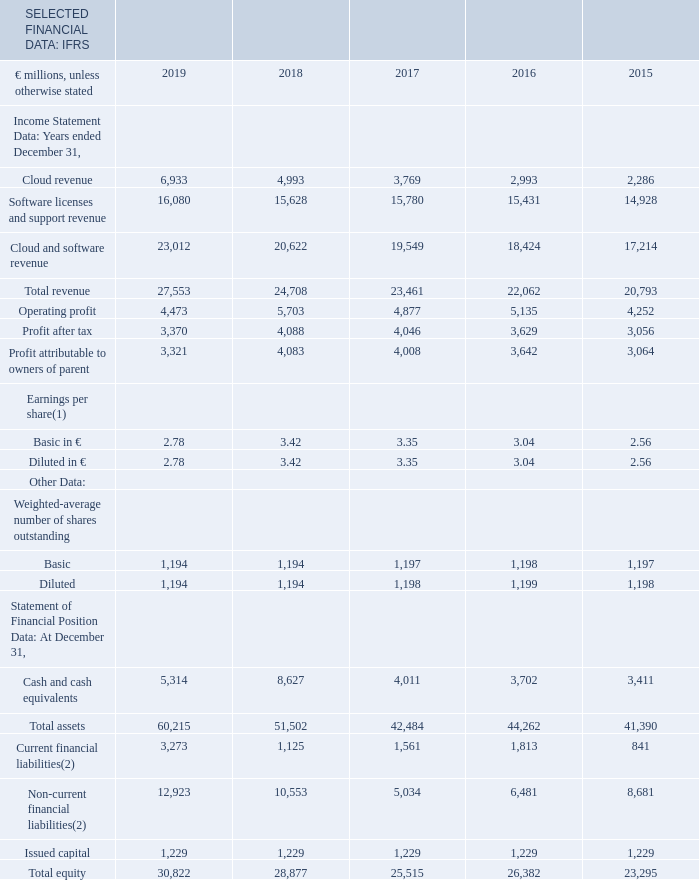ITEM 3. KEY INFORMATION
Selected Financial Data
The following table sets forth our selected consolidated financial data as of and for each of the years in the five-year period ended December 31, 2019. The consolidated financial data has been derived from, and should be read in conjunction with, our Consolidated Financial Statements prepared in accordance with International Financial Reporting Standards as issued by the International Accounting Standards Board (IFRS), presented in “Item 18. Financial Statements” of this report.
Our selected financial data and our Consolidated Financial Statements are presented in euros, unless otherwise stated.
(1) See Note (C.6) to our Consolidated Financial Statements for more information on earnings per share.
(2) The balances include primarily bonds, private placements and bank loans. See Note (E.3) to our Consolidated Financial Statements for more information on our financial liabilities.
Where is more information on earnings per share provided? Note (c.6) to our consolidated financial statements. What do the current and non-current financial liabilities balances include? Primarily bonds, private placements and bank loans. In which years was total equity calculated? 2019, 2018, 2017, 2016, 2015. In which year was the Basic earnings per share the largest? 3.42>3.35>3.04>2.78>2.56
Answer: 2018. What was the change in issued capital in 2019 from 2018?
Answer scale should be: million. 1,229-1,229
Answer: 0. What was the percentage change in issued capital in 2019 from 2018?
Answer scale should be: percent. (1,229-1,229)/1,229
Answer: 0. 